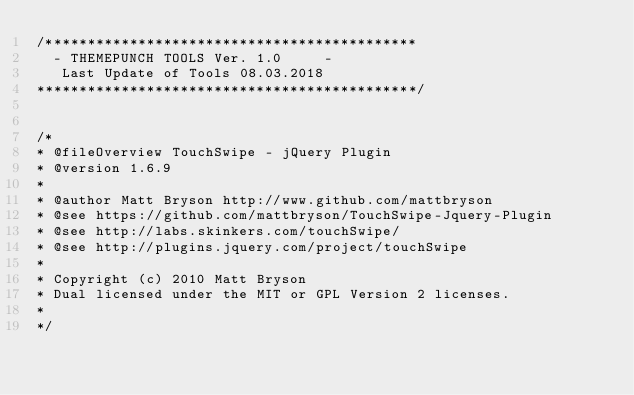<code> <loc_0><loc_0><loc_500><loc_500><_JavaScript_>/********************************************
	-	THEMEPUNCH TOOLS Ver. 1.0     -
	 Last Update of Tools 08.03.2018
*********************************************/


/*
* @fileOverview TouchSwipe - jQuery Plugin
* @version 1.6.9
*
* @author Matt Bryson http://www.github.com/mattbryson
* @see https://github.com/mattbryson/TouchSwipe-Jquery-Plugin
* @see http://labs.skinkers.com/touchSwipe/
* @see http://plugins.jquery.com/project/touchSwipe
*
* Copyright (c) 2010 Matt Bryson
* Dual licensed under the MIT or GPL Version 2 licenses.
*
*/


</code> 